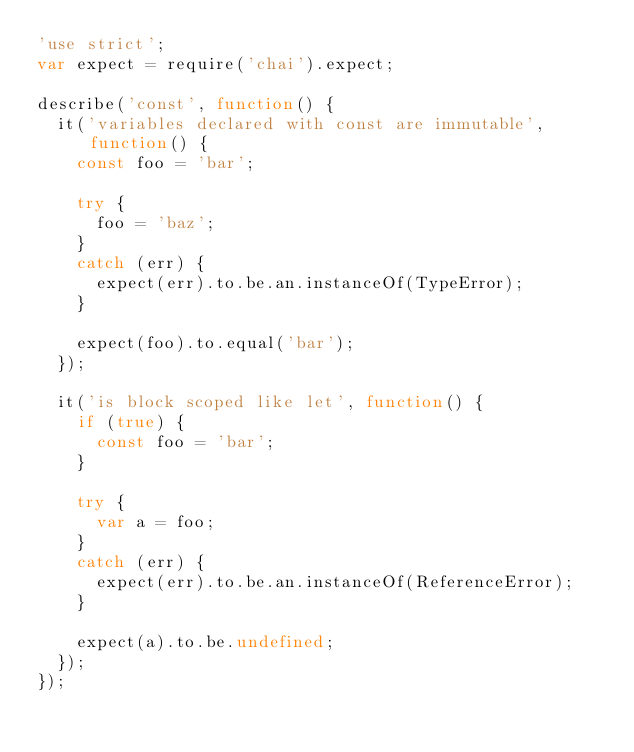Convert code to text. <code><loc_0><loc_0><loc_500><loc_500><_JavaScript_>'use strict';
var expect = require('chai').expect;

describe('const', function() {
  it('variables declared with const are immutable', function() {
    const foo = 'bar';

    try {
      foo = 'baz';
    }
    catch (err) {
      expect(err).to.be.an.instanceOf(TypeError);
    }

    expect(foo).to.equal('bar');
  });

  it('is block scoped like let', function() {
    if (true) {
      const foo = 'bar';
    }

    try {
      var a = foo;
    }
    catch (err) {
      expect(err).to.be.an.instanceOf(ReferenceError);
    }

    expect(a).to.be.undefined;
  });
});
</code> 